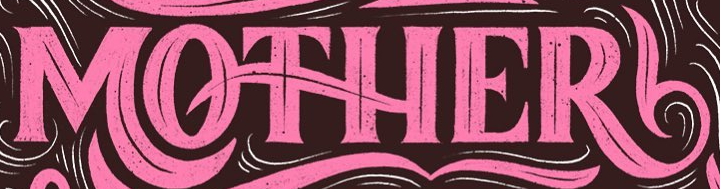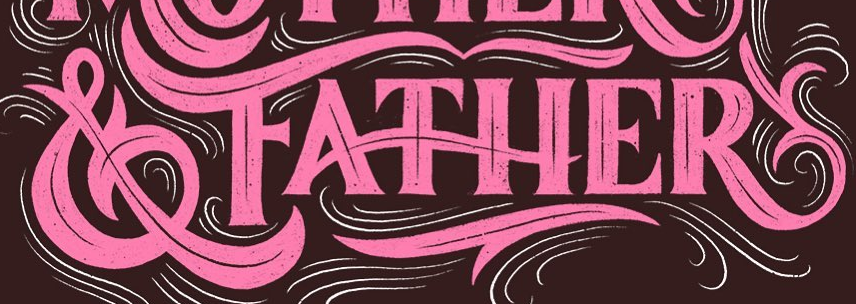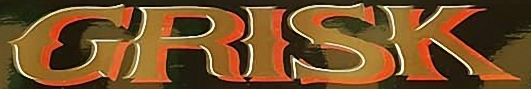Identify the words shown in these images in order, separated by a semicolon. MOTHER; &FATHER; GRISK 